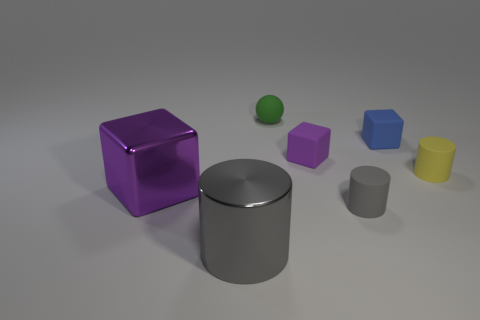Is the yellow cylinder made of the same material as the big object that is to the left of the gray shiny object?
Provide a short and direct response. No. There is a matte object that is on the right side of the small blue cube that is behind the tiny gray rubber thing; what number of large metal blocks are behind it?
Offer a terse response. 0. Do the small blue matte object and the gray object that is in front of the gray matte thing have the same shape?
Your answer should be compact. No. There is a thing that is to the left of the tiny blue thing and to the right of the purple rubber cube; what color is it?
Make the answer very short. Gray. There is a purple object to the right of the large metal thing that is in front of the purple block that is in front of the yellow matte cylinder; what is it made of?
Offer a terse response. Rubber. What is the small gray cylinder made of?
Your response must be concise. Rubber. There is a yellow rubber object that is the same shape as the big gray thing; what is its size?
Make the answer very short. Small. Is the tiny rubber ball the same color as the large metal cube?
Provide a short and direct response. No. What number of other things are made of the same material as the big purple object?
Your answer should be very brief. 1. Are there the same number of big gray objects behind the yellow rubber object and blocks?
Give a very brief answer. No. 